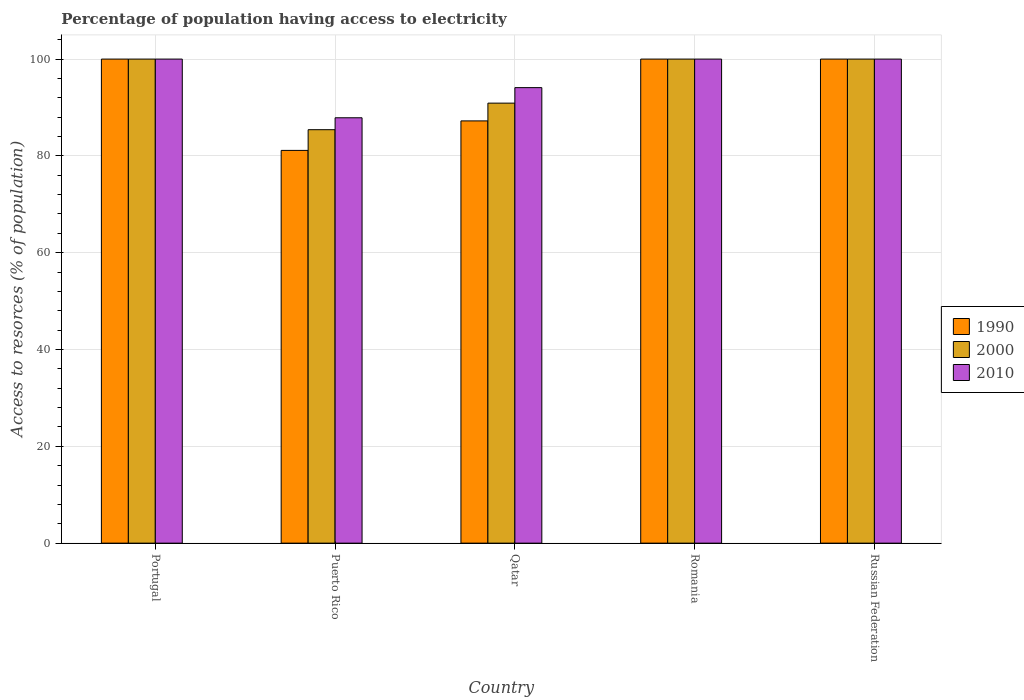How many different coloured bars are there?
Keep it short and to the point. 3. How many groups of bars are there?
Make the answer very short. 5. Are the number of bars per tick equal to the number of legend labels?
Provide a short and direct response. Yes. Are the number of bars on each tick of the X-axis equal?
Provide a succinct answer. Yes. How many bars are there on the 1st tick from the left?
Provide a succinct answer. 3. What is the label of the 1st group of bars from the left?
Provide a succinct answer. Portugal. In how many cases, is the number of bars for a given country not equal to the number of legend labels?
Offer a terse response. 0. Across all countries, what is the minimum percentage of population having access to electricity in 1990?
Your answer should be compact. 81.14. In which country was the percentage of population having access to electricity in 2000 maximum?
Your response must be concise. Portugal. In which country was the percentage of population having access to electricity in 2000 minimum?
Your answer should be very brief. Puerto Rico. What is the total percentage of population having access to electricity in 1990 in the graph?
Make the answer very short. 468.36. What is the difference between the percentage of population having access to electricity in 2000 in Qatar and the percentage of population having access to electricity in 2010 in Portugal?
Give a very brief answer. -9.1. What is the average percentage of population having access to electricity in 1990 per country?
Provide a short and direct response. 93.67. What is the difference between the percentage of population having access to electricity of/in 2000 and percentage of population having access to electricity of/in 2010 in Portugal?
Make the answer very short. 0. What is the ratio of the percentage of population having access to electricity in 1990 in Romania to that in Russian Federation?
Your answer should be compact. 1. Is the percentage of population having access to electricity in 2000 in Portugal less than that in Qatar?
Give a very brief answer. No. What is the difference between the highest and the lowest percentage of population having access to electricity in 2010?
Provide a succinct answer. 12.13. What does the 2nd bar from the left in Russian Federation represents?
Your response must be concise. 2000. How many countries are there in the graph?
Provide a succinct answer. 5. What is the difference between two consecutive major ticks on the Y-axis?
Provide a short and direct response. 20. Where does the legend appear in the graph?
Offer a terse response. Center right. What is the title of the graph?
Keep it short and to the point. Percentage of population having access to electricity. What is the label or title of the X-axis?
Offer a terse response. Country. What is the label or title of the Y-axis?
Your answer should be very brief. Access to resorces (% of population). What is the Access to resorces (% of population) of 1990 in Portugal?
Offer a very short reply. 100. What is the Access to resorces (% of population) in 2000 in Portugal?
Keep it short and to the point. 100. What is the Access to resorces (% of population) of 2010 in Portugal?
Give a very brief answer. 100. What is the Access to resorces (% of population) of 1990 in Puerto Rico?
Ensure brevity in your answer.  81.14. What is the Access to resorces (% of population) of 2000 in Puerto Rico?
Ensure brevity in your answer.  85.41. What is the Access to resorces (% of population) in 2010 in Puerto Rico?
Offer a very short reply. 87.87. What is the Access to resorces (% of population) of 1990 in Qatar?
Offer a very short reply. 87.23. What is the Access to resorces (% of population) of 2000 in Qatar?
Your response must be concise. 90.9. What is the Access to resorces (% of population) of 2010 in Qatar?
Provide a succinct answer. 94.1. What is the Access to resorces (% of population) of 2000 in Romania?
Your response must be concise. 100. What is the Access to resorces (% of population) of 2010 in Romania?
Keep it short and to the point. 100. What is the Access to resorces (% of population) in 1990 in Russian Federation?
Offer a terse response. 100. What is the Access to resorces (% of population) in 2000 in Russian Federation?
Your response must be concise. 100. Across all countries, what is the maximum Access to resorces (% of population) in 1990?
Make the answer very short. 100. Across all countries, what is the maximum Access to resorces (% of population) in 2000?
Offer a very short reply. 100. Across all countries, what is the minimum Access to resorces (% of population) of 1990?
Keep it short and to the point. 81.14. Across all countries, what is the minimum Access to resorces (% of population) of 2000?
Your answer should be compact. 85.41. Across all countries, what is the minimum Access to resorces (% of population) of 2010?
Give a very brief answer. 87.87. What is the total Access to resorces (% of population) of 1990 in the graph?
Your answer should be very brief. 468.36. What is the total Access to resorces (% of population) of 2000 in the graph?
Give a very brief answer. 476.31. What is the total Access to resorces (% of population) in 2010 in the graph?
Your response must be concise. 481.97. What is the difference between the Access to resorces (% of population) in 1990 in Portugal and that in Puerto Rico?
Provide a succinct answer. 18.86. What is the difference between the Access to resorces (% of population) in 2000 in Portugal and that in Puerto Rico?
Your answer should be compact. 14.59. What is the difference between the Access to resorces (% of population) in 2010 in Portugal and that in Puerto Rico?
Make the answer very short. 12.13. What is the difference between the Access to resorces (% of population) of 1990 in Portugal and that in Qatar?
Provide a short and direct response. 12.77. What is the difference between the Access to resorces (% of population) in 2000 in Portugal and that in Qatar?
Make the answer very short. 9.1. What is the difference between the Access to resorces (% of population) of 2010 in Portugal and that in Qatar?
Offer a very short reply. 5.9. What is the difference between the Access to resorces (% of population) in 2010 in Portugal and that in Romania?
Your answer should be very brief. 0. What is the difference between the Access to resorces (% of population) of 1990 in Puerto Rico and that in Qatar?
Keep it short and to the point. -6.09. What is the difference between the Access to resorces (% of population) in 2000 in Puerto Rico and that in Qatar?
Ensure brevity in your answer.  -5.49. What is the difference between the Access to resorces (% of population) of 2010 in Puerto Rico and that in Qatar?
Ensure brevity in your answer.  -6.23. What is the difference between the Access to resorces (% of population) in 1990 in Puerto Rico and that in Romania?
Ensure brevity in your answer.  -18.86. What is the difference between the Access to resorces (% of population) in 2000 in Puerto Rico and that in Romania?
Offer a terse response. -14.59. What is the difference between the Access to resorces (% of population) in 2010 in Puerto Rico and that in Romania?
Your answer should be compact. -12.13. What is the difference between the Access to resorces (% of population) of 1990 in Puerto Rico and that in Russian Federation?
Provide a succinct answer. -18.86. What is the difference between the Access to resorces (% of population) in 2000 in Puerto Rico and that in Russian Federation?
Give a very brief answer. -14.59. What is the difference between the Access to resorces (% of population) of 2010 in Puerto Rico and that in Russian Federation?
Offer a very short reply. -12.13. What is the difference between the Access to resorces (% of population) in 1990 in Qatar and that in Romania?
Provide a succinct answer. -12.77. What is the difference between the Access to resorces (% of population) in 2000 in Qatar and that in Romania?
Provide a short and direct response. -9.1. What is the difference between the Access to resorces (% of population) of 2010 in Qatar and that in Romania?
Make the answer very short. -5.9. What is the difference between the Access to resorces (% of population) in 1990 in Qatar and that in Russian Federation?
Provide a short and direct response. -12.77. What is the difference between the Access to resorces (% of population) of 2000 in Qatar and that in Russian Federation?
Provide a short and direct response. -9.1. What is the difference between the Access to resorces (% of population) of 1990 in Romania and that in Russian Federation?
Provide a short and direct response. 0. What is the difference between the Access to resorces (% of population) in 2010 in Romania and that in Russian Federation?
Provide a short and direct response. 0. What is the difference between the Access to resorces (% of population) in 1990 in Portugal and the Access to resorces (% of population) in 2000 in Puerto Rico?
Make the answer very short. 14.59. What is the difference between the Access to resorces (% of population) in 1990 in Portugal and the Access to resorces (% of population) in 2010 in Puerto Rico?
Your answer should be compact. 12.13. What is the difference between the Access to resorces (% of population) in 2000 in Portugal and the Access to resorces (% of population) in 2010 in Puerto Rico?
Your answer should be very brief. 12.13. What is the difference between the Access to resorces (% of population) in 1990 in Portugal and the Access to resorces (% of population) in 2000 in Qatar?
Provide a short and direct response. 9.1. What is the difference between the Access to resorces (% of population) in 2000 in Portugal and the Access to resorces (% of population) in 2010 in Qatar?
Give a very brief answer. 5.9. What is the difference between the Access to resorces (% of population) of 1990 in Portugal and the Access to resorces (% of population) of 2000 in Russian Federation?
Provide a short and direct response. 0. What is the difference between the Access to resorces (% of population) of 1990 in Puerto Rico and the Access to resorces (% of population) of 2000 in Qatar?
Offer a terse response. -9.76. What is the difference between the Access to resorces (% of population) of 1990 in Puerto Rico and the Access to resorces (% of population) of 2010 in Qatar?
Keep it short and to the point. -12.96. What is the difference between the Access to resorces (% of population) in 2000 in Puerto Rico and the Access to resorces (% of population) in 2010 in Qatar?
Offer a very short reply. -8.69. What is the difference between the Access to resorces (% of population) of 1990 in Puerto Rico and the Access to resorces (% of population) of 2000 in Romania?
Give a very brief answer. -18.86. What is the difference between the Access to resorces (% of population) of 1990 in Puerto Rico and the Access to resorces (% of population) of 2010 in Romania?
Your answer should be very brief. -18.86. What is the difference between the Access to resorces (% of population) in 2000 in Puerto Rico and the Access to resorces (% of population) in 2010 in Romania?
Offer a terse response. -14.59. What is the difference between the Access to resorces (% of population) of 1990 in Puerto Rico and the Access to resorces (% of population) of 2000 in Russian Federation?
Offer a very short reply. -18.86. What is the difference between the Access to resorces (% of population) in 1990 in Puerto Rico and the Access to resorces (% of population) in 2010 in Russian Federation?
Offer a very short reply. -18.86. What is the difference between the Access to resorces (% of population) of 2000 in Puerto Rico and the Access to resorces (% of population) of 2010 in Russian Federation?
Your answer should be very brief. -14.59. What is the difference between the Access to resorces (% of population) of 1990 in Qatar and the Access to resorces (% of population) of 2000 in Romania?
Your answer should be very brief. -12.77. What is the difference between the Access to resorces (% of population) of 1990 in Qatar and the Access to resorces (% of population) of 2010 in Romania?
Provide a short and direct response. -12.77. What is the difference between the Access to resorces (% of population) of 2000 in Qatar and the Access to resorces (% of population) of 2010 in Romania?
Provide a short and direct response. -9.1. What is the difference between the Access to resorces (% of population) of 1990 in Qatar and the Access to resorces (% of population) of 2000 in Russian Federation?
Your answer should be very brief. -12.77. What is the difference between the Access to resorces (% of population) in 1990 in Qatar and the Access to resorces (% of population) in 2010 in Russian Federation?
Ensure brevity in your answer.  -12.77. What is the difference between the Access to resorces (% of population) of 2000 in Qatar and the Access to resorces (% of population) of 2010 in Russian Federation?
Give a very brief answer. -9.1. What is the difference between the Access to resorces (% of population) of 1990 in Romania and the Access to resorces (% of population) of 2000 in Russian Federation?
Keep it short and to the point. 0. What is the average Access to resorces (% of population) of 1990 per country?
Your response must be concise. 93.67. What is the average Access to resorces (% of population) in 2000 per country?
Offer a very short reply. 95.26. What is the average Access to resorces (% of population) of 2010 per country?
Ensure brevity in your answer.  96.39. What is the difference between the Access to resorces (% of population) of 1990 and Access to resorces (% of population) of 2010 in Portugal?
Make the answer very short. 0. What is the difference between the Access to resorces (% of population) of 2000 and Access to resorces (% of population) of 2010 in Portugal?
Your response must be concise. 0. What is the difference between the Access to resorces (% of population) of 1990 and Access to resorces (% of population) of 2000 in Puerto Rico?
Provide a short and direct response. -4.28. What is the difference between the Access to resorces (% of population) of 1990 and Access to resorces (% of population) of 2010 in Puerto Rico?
Give a very brief answer. -6.74. What is the difference between the Access to resorces (% of population) in 2000 and Access to resorces (% of population) in 2010 in Puerto Rico?
Provide a short and direct response. -2.46. What is the difference between the Access to resorces (% of population) of 1990 and Access to resorces (% of population) of 2000 in Qatar?
Offer a very short reply. -3.67. What is the difference between the Access to resorces (% of population) in 1990 and Access to resorces (% of population) in 2010 in Qatar?
Offer a very short reply. -6.87. What is the difference between the Access to resorces (% of population) in 2000 and Access to resorces (% of population) in 2010 in Qatar?
Provide a succinct answer. -3.2. What is the difference between the Access to resorces (% of population) of 1990 and Access to resorces (% of population) of 2000 in Romania?
Provide a succinct answer. 0. What is the difference between the Access to resorces (% of population) in 1990 and Access to resorces (% of population) in 2010 in Romania?
Provide a succinct answer. 0. What is the difference between the Access to resorces (% of population) of 1990 and Access to resorces (% of population) of 2010 in Russian Federation?
Keep it short and to the point. 0. What is the ratio of the Access to resorces (% of population) in 1990 in Portugal to that in Puerto Rico?
Keep it short and to the point. 1.23. What is the ratio of the Access to resorces (% of population) of 2000 in Portugal to that in Puerto Rico?
Give a very brief answer. 1.17. What is the ratio of the Access to resorces (% of population) in 2010 in Portugal to that in Puerto Rico?
Your response must be concise. 1.14. What is the ratio of the Access to resorces (% of population) of 1990 in Portugal to that in Qatar?
Offer a very short reply. 1.15. What is the ratio of the Access to resorces (% of population) in 2000 in Portugal to that in Qatar?
Your answer should be very brief. 1.1. What is the ratio of the Access to resorces (% of population) of 2010 in Portugal to that in Qatar?
Your answer should be compact. 1.06. What is the ratio of the Access to resorces (% of population) of 2000 in Portugal to that in Romania?
Keep it short and to the point. 1. What is the ratio of the Access to resorces (% of population) of 2010 in Portugal to that in Romania?
Make the answer very short. 1. What is the ratio of the Access to resorces (% of population) in 1990 in Portugal to that in Russian Federation?
Provide a short and direct response. 1. What is the ratio of the Access to resorces (% of population) of 2000 in Portugal to that in Russian Federation?
Provide a succinct answer. 1. What is the ratio of the Access to resorces (% of population) in 1990 in Puerto Rico to that in Qatar?
Your response must be concise. 0.93. What is the ratio of the Access to resorces (% of population) in 2000 in Puerto Rico to that in Qatar?
Provide a succinct answer. 0.94. What is the ratio of the Access to resorces (% of population) in 2010 in Puerto Rico to that in Qatar?
Ensure brevity in your answer.  0.93. What is the ratio of the Access to resorces (% of population) of 1990 in Puerto Rico to that in Romania?
Give a very brief answer. 0.81. What is the ratio of the Access to resorces (% of population) of 2000 in Puerto Rico to that in Romania?
Provide a succinct answer. 0.85. What is the ratio of the Access to resorces (% of population) in 2010 in Puerto Rico to that in Romania?
Provide a succinct answer. 0.88. What is the ratio of the Access to resorces (% of population) of 1990 in Puerto Rico to that in Russian Federation?
Ensure brevity in your answer.  0.81. What is the ratio of the Access to resorces (% of population) in 2000 in Puerto Rico to that in Russian Federation?
Make the answer very short. 0.85. What is the ratio of the Access to resorces (% of population) in 2010 in Puerto Rico to that in Russian Federation?
Offer a terse response. 0.88. What is the ratio of the Access to resorces (% of population) in 1990 in Qatar to that in Romania?
Make the answer very short. 0.87. What is the ratio of the Access to resorces (% of population) of 2000 in Qatar to that in Romania?
Provide a succinct answer. 0.91. What is the ratio of the Access to resorces (% of population) in 2010 in Qatar to that in Romania?
Your response must be concise. 0.94. What is the ratio of the Access to resorces (% of population) of 1990 in Qatar to that in Russian Federation?
Give a very brief answer. 0.87. What is the ratio of the Access to resorces (% of population) of 2000 in Qatar to that in Russian Federation?
Provide a short and direct response. 0.91. What is the ratio of the Access to resorces (% of population) in 2010 in Qatar to that in Russian Federation?
Keep it short and to the point. 0.94. What is the ratio of the Access to resorces (% of population) of 1990 in Romania to that in Russian Federation?
Offer a very short reply. 1. What is the ratio of the Access to resorces (% of population) in 2010 in Romania to that in Russian Federation?
Ensure brevity in your answer.  1. What is the difference between the highest and the second highest Access to resorces (% of population) of 1990?
Make the answer very short. 0. What is the difference between the highest and the lowest Access to resorces (% of population) of 1990?
Ensure brevity in your answer.  18.86. What is the difference between the highest and the lowest Access to resorces (% of population) in 2000?
Provide a succinct answer. 14.59. What is the difference between the highest and the lowest Access to resorces (% of population) of 2010?
Make the answer very short. 12.13. 